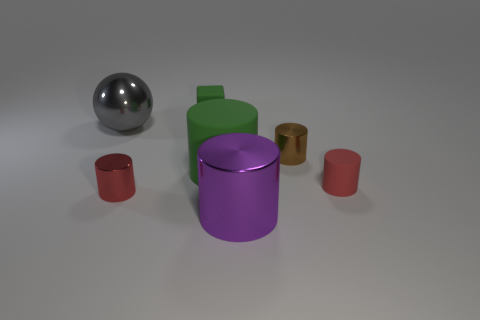Subtract all brown cylinders. How many cylinders are left? 4 Subtract all green cylinders. How many cylinders are left? 4 Subtract all cyan cylinders. Subtract all green spheres. How many cylinders are left? 5 Add 1 large red rubber blocks. How many objects exist? 8 Subtract all cylinders. How many objects are left? 2 Subtract all balls. Subtract all large green objects. How many objects are left? 5 Add 5 cylinders. How many cylinders are left? 10 Add 3 big purple metallic cylinders. How many big purple metallic cylinders exist? 4 Subtract 0 brown balls. How many objects are left? 7 